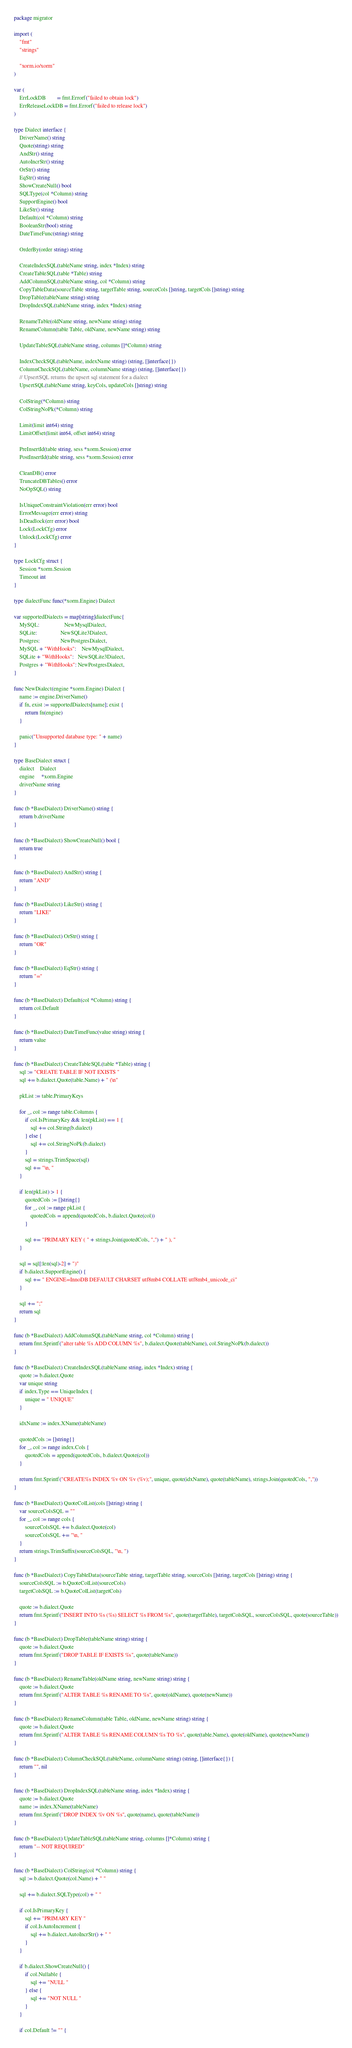<code> <loc_0><loc_0><loc_500><loc_500><_Go_>package migrator

import (
	"fmt"
	"strings"

	"xorm.io/xorm"
)

var (
	ErrLockDB        = fmt.Errorf("failed to obtain lock")
	ErrReleaseLockDB = fmt.Errorf("failed to release lock")
)

type Dialect interface {
	DriverName() string
	Quote(string) string
	AndStr() string
	AutoIncrStr() string
	OrStr() string
	EqStr() string
	ShowCreateNull() bool
	SQLType(col *Column) string
	SupportEngine() bool
	LikeStr() string
	Default(col *Column) string
	BooleanStr(bool) string
	DateTimeFunc(string) string

	OrderBy(order string) string

	CreateIndexSQL(tableName string, index *Index) string
	CreateTableSQL(table *Table) string
	AddColumnSQL(tableName string, col *Column) string
	CopyTableData(sourceTable string, targetTable string, sourceCols []string, targetCols []string) string
	DropTable(tableName string) string
	DropIndexSQL(tableName string, index *Index) string

	RenameTable(oldName string, newName string) string
	RenameColumn(table Table, oldName, newName string) string

	UpdateTableSQL(tableName string, columns []*Column) string

	IndexCheckSQL(tableName, indexName string) (string, []interface{})
	ColumnCheckSQL(tableName, columnName string) (string, []interface{})
	// UpsertSQL returns the upsert sql statement for a dialect
	UpsertSQL(tableName string, keyCols, updateCols []string) string

	ColString(*Column) string
	ColStringNoPk(*Column) string

	Limit(limit int64) string
	LimitOffset(limit int64, offset int64) string

	PreInsertId(table string, sess *xorm.Session) error
	PostInsertId(table string, sess *xorm.Session) error

	CleanDB() error
	TruncateDBTables() error
	NoOpSQL() string

	IsUniqueConstraintViolation(err error) bool
	ErrorMessage(err error) string
	IsDeadlock(err error) bool
	Lock(LockCfg) error
	Unlock(LockCfg) error
}

type LockCfg struct {
	Session *xorm.Session
	Timeout int
}

type dialectFunc func(*xorm.Engine) Dialect

var supportedDialects = map[string]dialectFunc{
	MySQL:                  NewMysqlDialect,
	SQLite:                 NewSQLite3Dialect,
	Postgres:               NewPostgresDialect,
	MySQL + "WithHooks":    NewMysqlDialect,
	SQLite + "WithHooks":   NewSQLite3Dialect,
	Postgres + "WithHooks": NewPostgresDialect,
}

func NewDialect(engine *xorm.Engine) Dialect {
	name := engine.DriverName()
	if fn, exist := supportedDialects[name]; exist {
		return fn(engine)
	}

	panic("Unsupported database type: " + name)
}

type BaseDialect struct {
	dialect    Dialect
	engine     *xorm.Engine
	driverName string
}

func (b *BaseDialect) DriverName() string {
	return b.driverName
}

func (b *BaseDialect) ShowCreateNull() bool {
	return true
}

func (b *BaseDialect) AndStr() string {
	return "AND"
}

func (b *BaseDialect) LikeStr() string {
	return "LIKE"
}

func (b *BaseDialect) OrStr() string {
	return "OR"
}

func (b *BaseDialect) EqStr() string {
	return "="
}

func (b *BaseDialect) Default(col *Column) string {
	return col.Default
}

func (b *BaseDialect) DateTimeFunc(value string) string {
	return value
}

func (b *BaseDialect) CreateTableSQL(table *Table) string {
	sql := "CREATE TABLE IF NOT EXISTS "
	sql += b.dialect.Quote(table.Name) + " (\n"

	pkList := table.PrimaryKeys

	for _, col := range table.Columns {
		if col.IsPrimaryKey && len(pkList) == 1 {
			sql += col.String(b.dialect)
		} else {
			sql += col.StringNoPk(b.dialect)
		}
		sql = strings.TrimSpace(sql)
		sql += "\n, "
	}

	if len(pkList) > 1 {
		quotedCols := []string{}
		for _, col := range pkList {
			quotedCols = append(quotedCols, b.dialect.Quote(col))
		}

		sql += "PRIMARY KEY ( " + strings.Join(quotedCols, ",") + " ), "
	}

	sql = sql[:len(sql)-2] + ")"
	if b.dialect.SupportEngine() {
		sql += " ENGINE=InnoDB DEFAULT CHARSET utf8mb4 COLLATE utf8mb4_unicode_ci"
	}

	sql += ";"
	return sql
}

func (b *BaseDialect) AddColumnSQL(tableName string, col *Column) string {
	return fmt.Sprintf("alter table %s ADD COLUMN %s", b.dialect.Quote(tableName), col.StringNoPk(b.dialect))
}

func (b *BaseDialect) CreateIndexSQL(tableName string, index *Index) string {
	quote := b.dialect.Quote
	var unique string
	if index.Type == UniqueIndex {
		unique = " UNIQUE"
	}

	idxName := index.XName(tableName)

	quotedCols := []string{}
	for _, col := range index.Cols {
		quotedCols = append(quotedCols, b.dialect.Quote(col))
	}

	return fmt.Sprintf("CREATE%s INDEX %v ON %v (%v);", unique, quote(idxName), quote(tableName), strings.Join(quotedCols, ","))
}

func (b *BaseDialect) QuoteColList(cols []string) string {
	var sourceColsSQL = ""
	for _, col := range cols {
		sourceColsSQL += b.dialect.Quote(col)
		sourceColsSQL += "\n, "
	}
	return strings.TrimSuffix(sourceColsSQL, "\n, ")
}

func (b *BaseDialect) CopyTableData(sourceTable string, targetTable string, sourceCols []string, targetCols []string) string {
	sourceColsSQL := b.QuoteColList(sourceCols)
	targetColsSQL := b.QuoteColList(targetCols)

	quote := b.dialect.Quote
	return fmt.Sprintf("INSERT INTO %s (%s) SELECT %s FROM %s", quote(targetTable), targetColsSQL, sourceColsSQL, quote(sourceTable))
}

func (b *BaseDialect) DropTable(tableName string) string {
	quote := b.dialect.Quote
	return fmt.Sprintf("DROP TABLE IF EXISTS %s", quote(tableName))
}

func (b *BaseDialect) RenameTable(oldName string, newName string) string {
	quote := b.dialect.Quote
	return fmt.Sprintf("ALTER TABLE %s RENAME TO %s", quote(oldName), quote(newName))
}

func (b *BaseDialect) RenameColumn(table Table, oldName, newName string) string {
	quote := b.dialect.Quote
	return fmt.Sprintf("ALTER TABLE %s RENAME COLUMN %s TO %s", quote(table.Name), quote(oldName), quote(newName))
}

func (b *BaseDialect) ColumnCheckSQL(tableName, columnName string) (string, []interface{}) {
	return "", nil
}

func (b *BaseDialect) DropIndexSQL(tableName string, index *Index) string {
	quote := b.dialect.Quote
	name := index.XName(tableName)
	return fmt.Sprintf("DROP INDEX %v ON %s", quote(name), quote(tableName))
}

func (b *BaseDialect) UpdateTableSQL(tableName string, columns []*Column) string {
	return "-- NOT REQUIRED"
}

func (b *BaseDialect) ColString(col *Column) string {
	sql := b.dialect.Quote(col.Name) + " "

	sql += b.dialect.SQLType(col) + " "

	if col.IsPrimaryKey {
		sql += "PRIMARY KEY "
		if col.IsAutoIncrement {
			sql += b.dialect.AutoIncrStr() + " "
		}
	}

	if b.dialect.ShowCreateNull() {
		if col.Nullable {
			sql += "NULL "
		} else {
			sql += "NOT NULL "
		}
	}

	if col.Default != "" {</code> 